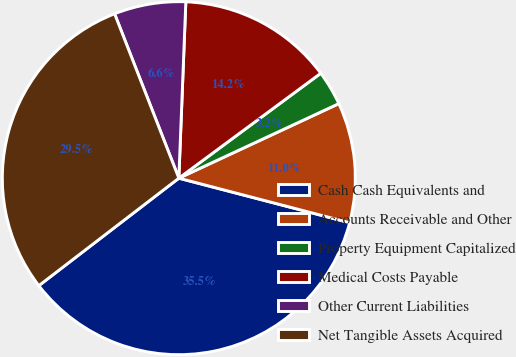Convert chart to OTSL. <chart><loc_0><loc_0><loc_500><loc_500><pie_chart><fcel>Cash Cash Equivalents and<fcel>Accounts Receivable and Other<fcel>Property Equipment Capitalized<fcel>Medical Costs Payable<fcel>Other Current Liabilities<fcel>Net Tangible Assets Acquired<nl><fcel>35.52%<fcel>11.0%<fcel>3.19%<fcel>14.24%<fcel>6.56%<fcel>29.49%<nl></chart> 